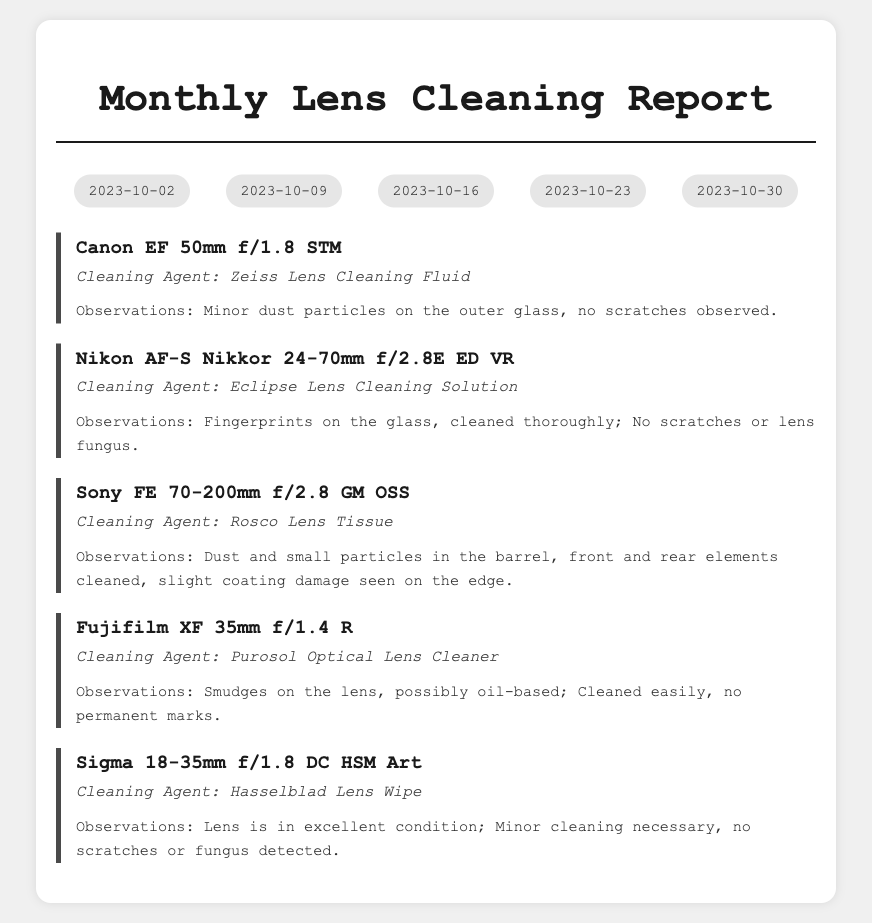What date was the first lens cleaned? The first date in the cleaning dates section is 2023-10-02, which is when the first lens was cleaned.
Answer: 2023-10-02 What type of lens was cleaned on 2023-10-09? The lens cleaned on this date is mentioned immediately following the corresponding date, which is the Nikon AF-S Nikkor 24-70mm f/2.8E ED VR.
Answer: Nikon AF-S Nikkor 24-70mm f/2.8E ED VR How many lenses were cleaned in total during the month? The document lists five different lenses cleaned, which can be counted from the lens report sections.
Answer: 5 What cleaning agent was used for the Canon EF 50mm f/1.8 STM? The cleaning agent used for this lens is specified directly in the cleaning report for the lens, which is Zeiss Lens Cleaning Fluid.
Answer: Zeiss Lens Cleaning Fluid What observation was made regarding the Sony FE 70-200mm f/2.8 GM OSS lens? The observations for this lens indicate that there is dust and small particles, along with slight coating damage on the edge.
Answer: Dust and small particles; slight coating damage seen on the edge Did any lens show signs of scratches? The observations in the document note that both the Canon EF 50mm f/1.8 STM and Nikon AF-S Nikkor 24-70mm f/2.8E ED VR showed no scratches, while others had various conditions.
Answer: No Which lens was reported to be in excellent condition? The report for the Sigma 18-35mm f/1.8 DC HSM Art specifically mentions that the lens is in excellent condition.
Answer: Sigma 18-35mm f/1.8 DC HSM Art What type of cleaning agent was used to clean the Fujifilm XF 35mm f/1.4 R? The report specifies the cleaning agent used for this lens as Purosol Optical Lens Cleaner.
Answer: Purosol Optical Lens Cleaner 